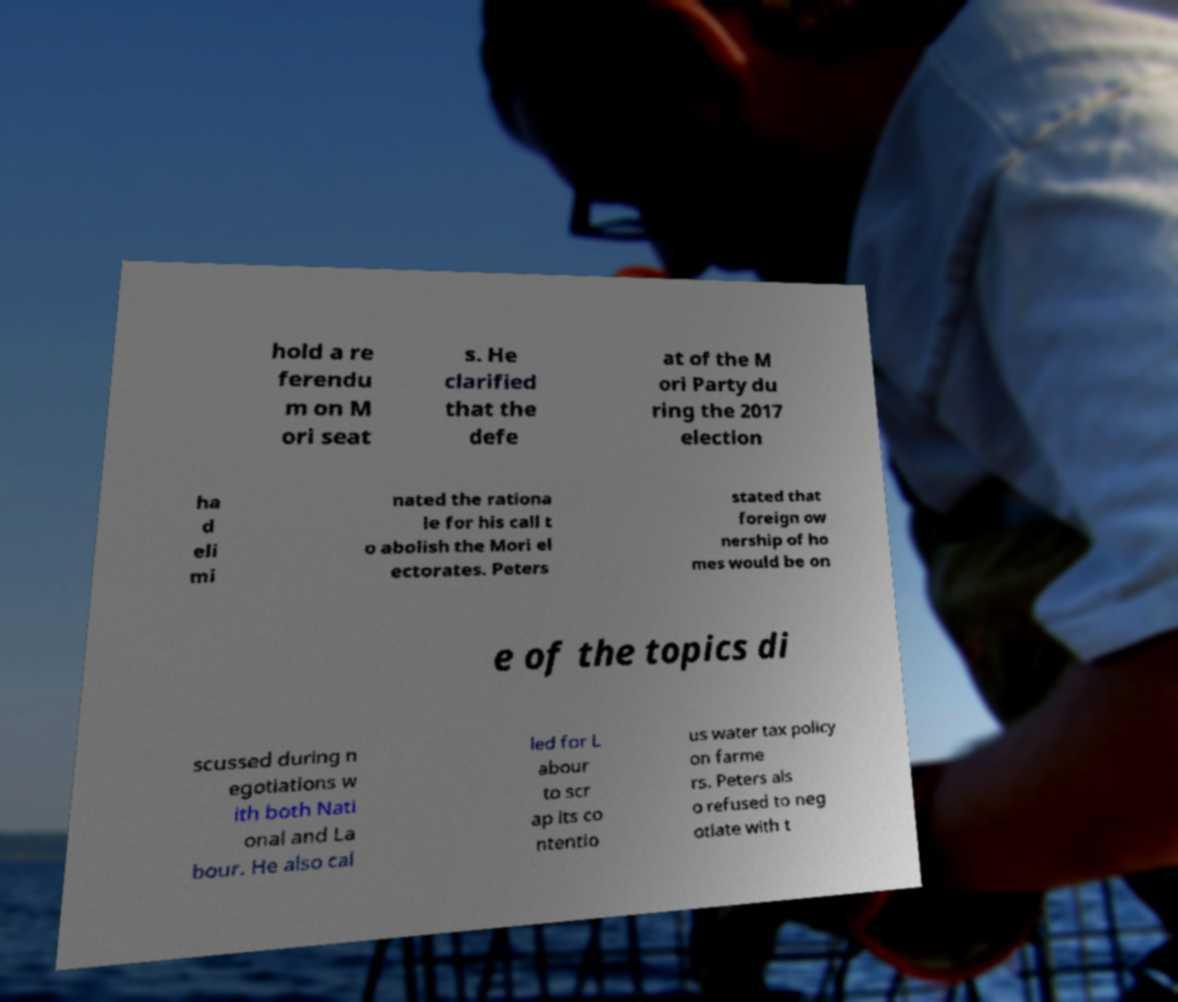I need the written content from this picture converted into text. Can you do that? hold a re ferendu m on M ori seat s. He clarified that the defe at of the M ori Party du ring the 2017 election ha d eli mi nated the rationa le for his call t o abolish the Mori el ectorates. Peters stated that foreign ow nership of ho mes would be on e of the topics di scussed during n egotiations w ith both Nati onal and La bour. He also cal led for L abour to scr ap its co ntentio us water tax policy on farme rs. Peters als o refused to neg otiate with t 